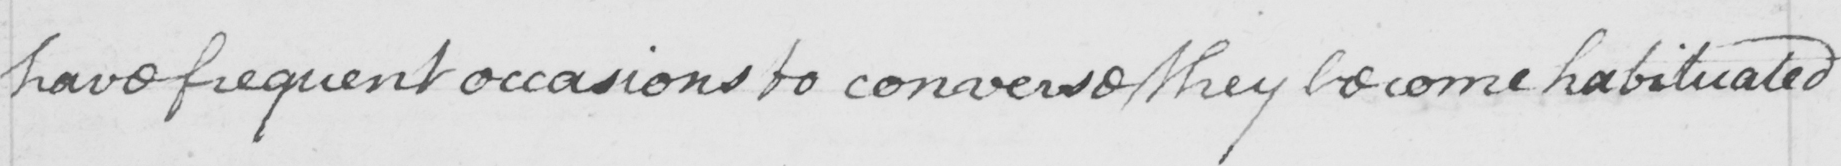Please transcribe the handwritten text in this image. have frequent occasions to converse & they become habituated 